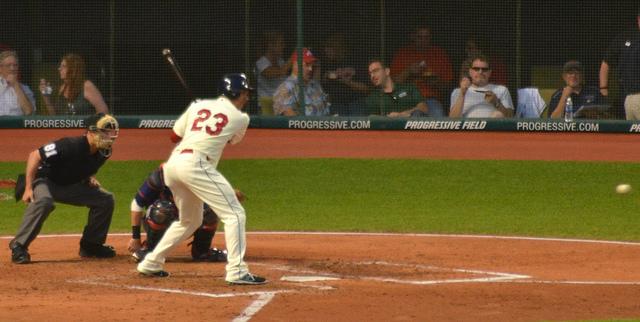What number is on the man's shirt?
Write a very short answer. 23. What sport is being played?
Be succinct. Baseball. What advertiser is shown?
Answer briefly. Progressive. 